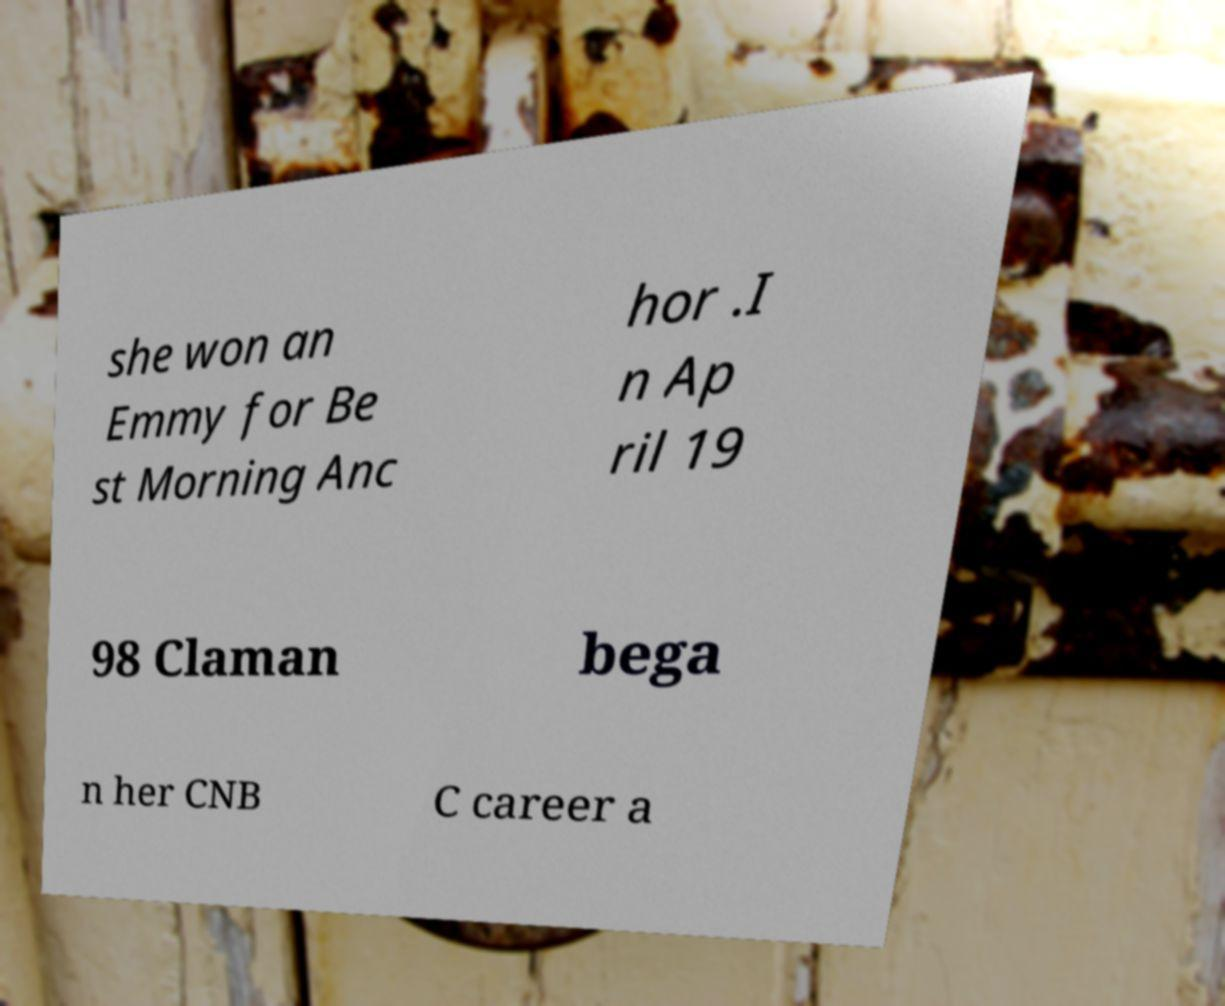There's text embedded in this image that I need extracted. Can you transcribe it verbatim? she won an Emmy for Be st Morning Anc hor .I n Ap ril 19 98 Claman bega n her CNB C career a 